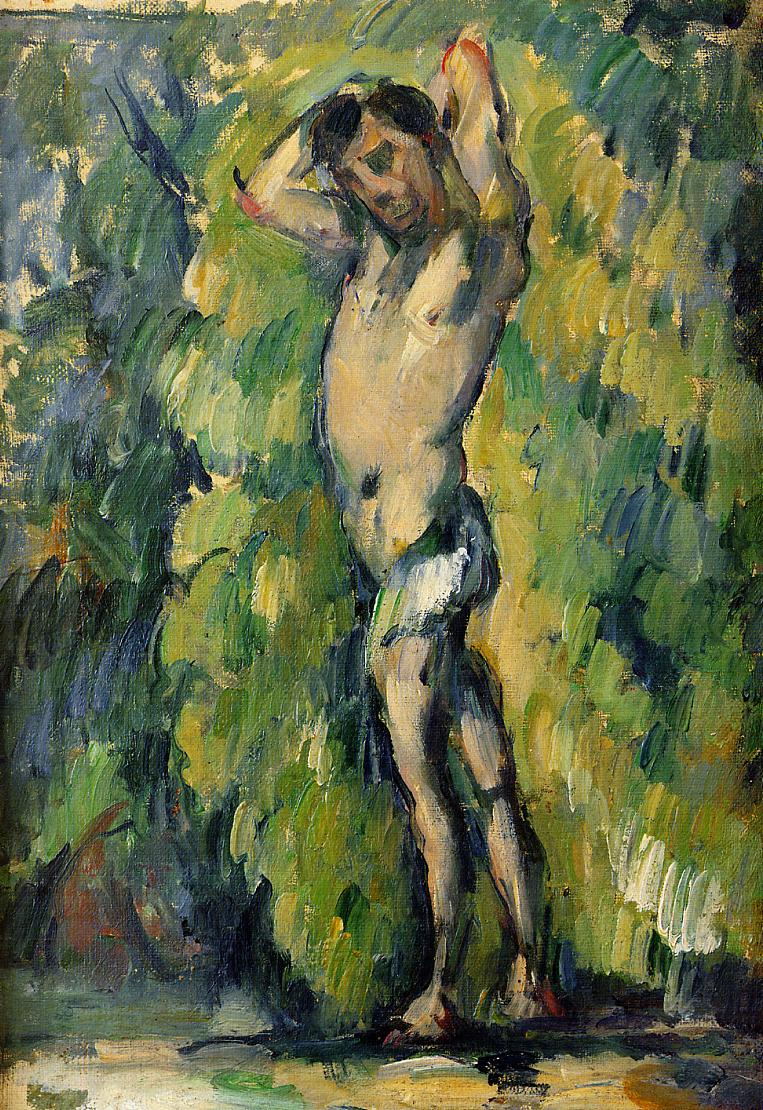What do you think is going on in this snapshot? The image appears to be an impressionist painting capturing a scene of a nude man standing amid lush greenery. The man's pose, with arms raised above his head, conveys a possible sense of exuberance or an intimate connection with nature. Through vigorous and quick brushstrokes, the artist has created a vibrant tapestry of greens and earthen colors, typical of impressionist methods aiming to record the effects of light. While the individual's features are not detailed, the human form, especially the muscles and contours of the body, is expressively rendered, giving the painting a dynamic feel amidst the tranquil forest setting. 